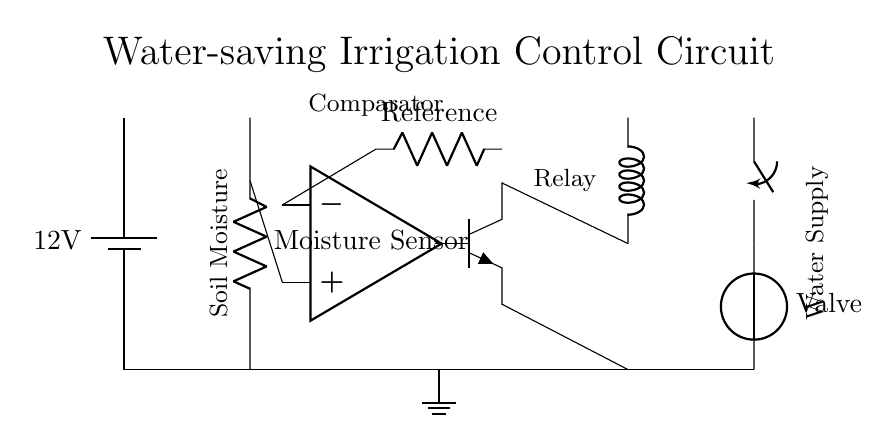what is the power supply voltage for this circuit? The diagram indicates a power supply with a label showing it as 12 volts. This is the voltage that powers the entire circuit.
Answer: 12 volts what component is used to detect soil moisture? The circuit features a component labeled as "Moisture Sensor." This sensor is responsible for measuring the moisture level in the soil.
Answer: Moisture Sensor what type of transistor is used in this circuit? The circuit diagram shows an npn transistor, which is a type of bipolar junction transistor commonly used in switching applications.
Answer: npn what is the function of the comparator in this circuit? The comparator compares the voltage from the moisture sensor with a reference voltage. Depending on the comparison, it outputs a signal to control the transistor.
Answer: Control voltage how does the relay function in this irrigation system? The relay is activated by the output from the transistor when the soil moisture levels fall below a certain threshold. This activation allows water from the supply to flow through the valve.
Answer: Activate water flow what is the purpose of the reference resistor connected to the comparator? The reference resistor sets a predetermined voltage level against which the moisture sensor's voltage can be compared in order to determine if irrigation is needed.
Answer: Setting comparison level what happens when the soil moisture is low? When the soil moisture is detected to be low, the comparator's output changes, turning on the npn transistor, which activates the relay to open the valve and allow water flow.
Answer: Open valve 